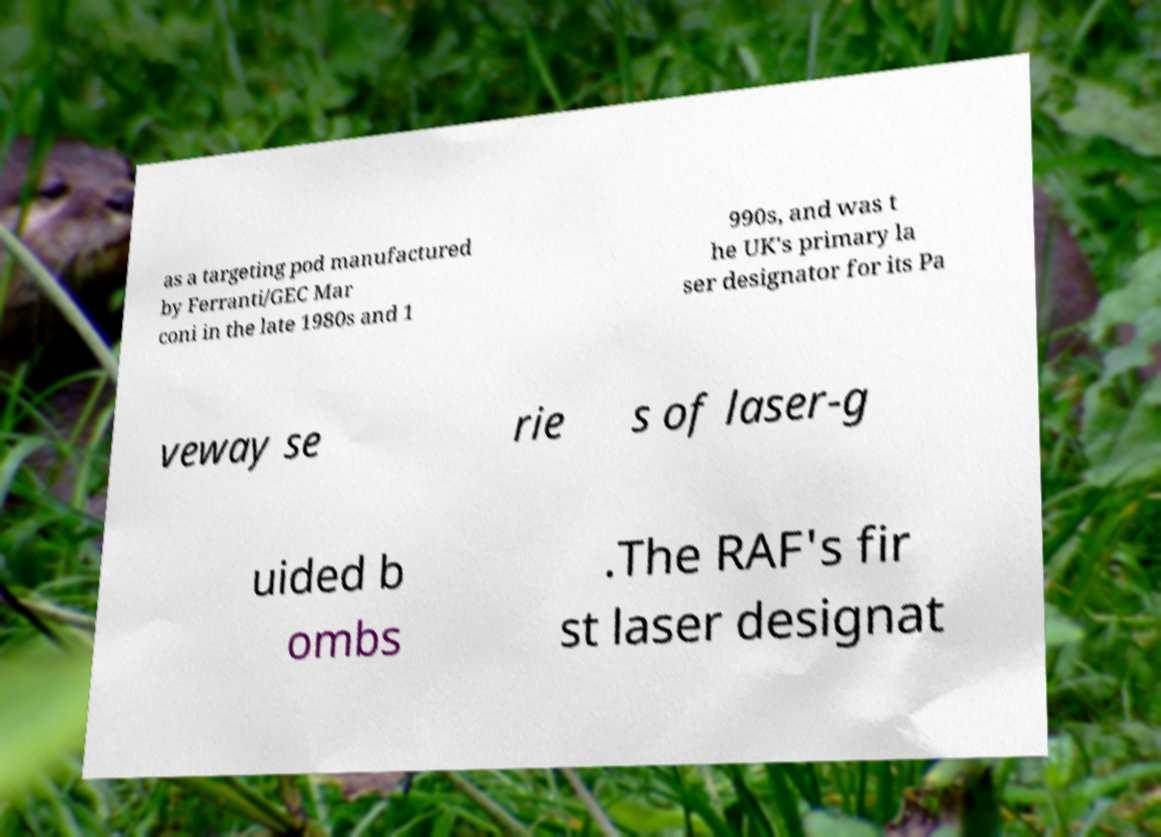Please identify and transcribe the text found in this image. as a targeting pod manufactured by Ferranti/GEC Mar coni in the late 1980s and 1 990s, and was t he UK's primary la ser designator for its Pa veway se rie s of laser-g uided b ombs .The RAF's fir st laser designat 